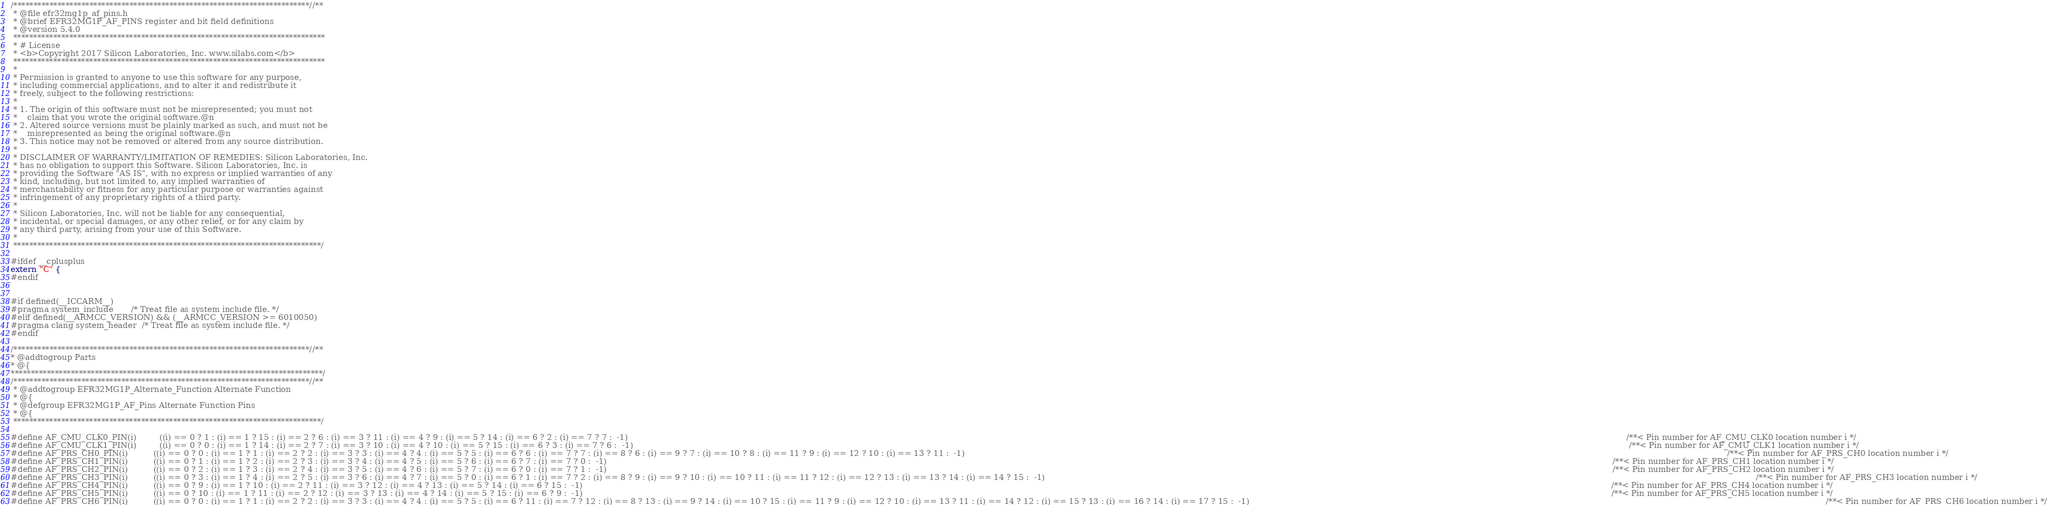<code> <loc_0><loc_0><loc_500><loc_500><_C_>/**************************************************************************//**
 * @file efr32mg1p_af_pins.h
 * @brief EFR32MG1P_AF_PINS register and bit field definitions
 * @version 5.4.0
 ******************************************************************************
 * # License
 * <b>Copyright 2017 Silicon Laboratories, Inc. www.silabs.com</b>
 ******************************************************************************
 *
 * Permission is granted to anyone to use this software for any purpose,
 * including commercial applications, and to alter it and redistribute it
 * freely, subject to the following restrictions:
 *
 * 1. The origin of this software must not be misrepresented; you must not
 *    claim that you wrote the original software.@n
 * 2. Altered source versions must be plainly marked as such, and must not be
 *    misrepresented as being the original software.@n
 * 3. This notice may not be removed or altered from any source distribution.
 *
 * DISCLAIMER OF WARRANTY/LIMITATION OF REMEDIES: Silicon Laboratories, Inc.
 * has no obligation to support this Software. Silicon Laboratories, Inc. is
 * providing the Software "AS IS", with no express or implied warranties of any
 * kind, including, but not limited to, any implied warranties of
 * merchantability or fitness for any particular purpose or warranties against
 * infringement of any proprietary rights of a third party.
 *
 * Silicon Laboratories, Inc. will not be liable for any consequential,
 * incidental, or special damages, or any other relief, or for any claim by
 * any third party, arising from your use of this Software.
 *
 *****************************************************************************/

#ifdef __cplusplus
extern "C" {
#endif


#if defined(__ICCARM__)
#pragma system_include       /* Treat file as system include file. */
#elif defined(__ARMCC_VERSION) && (__ARMCC_VERSION >= 6010050)
#pragma clang system_header  /* Treat file as system include file. */
#endif

/**************************************************************************//**
* @addtogroup Parts
* @{
******************************************************************************/
/**************************************************************************//**
 * @addtogroup EFR32MG1P_Alternate_Function Alternate Function
 * @{
 * @defgroup EFR32MG1P_AF_Pins Alternate Function Pins
 * @{
 *****************************************************************************/

#define AF_CMU_CLK0_PIN(i)         ((i) == 0 ? 1 : (i) == 1 ? 15 : (i) == 2 ? 6 : (i) == 3 ? 11 : (i) == 4 ? 9 : (i) == 5 ? 14 : (i) == 6 ? 2 : (i) == 7 ? 7 :  -1)                                                                                                                                                                                                                                                                                                                                                                                                         /**< Pin number for AF_CMU_CLK0 location number i */
#define AF_CMU_CLK1_PIN(i)         ((i) == 0 ? 0 : (i) == 1 ? 14 : (i) == 2 ? 7 : (i) == 3 ? 10 : (i) == 4 ? 10 : (i) == 5 ? 15 : (i) == 6 ? 3 : (i) == 7 ? 6 :  -1)                                                                                                                                                                                                                                                                                                                                                                                                        /**< Pin number for AF_CMU_CLK1 location number i */
#define AF_PRS_CH0_PIN(i)          ((i) == 0 ? 0 : (i) == 1 ? 1 : (i) == 2 ? 2 : (i) == 3 ? 3 : (i) == 4 ? 4 : (i) == 5 ? 5 : (i) == 6 ? 6 : (i) == 7 ? 7 : (i) == 8 ? 6 : (i) == 9 ? 7 : (i) == 10 ? 8 : (i) == 11 ? 9 : (i) == 12 ? 10 : (i) == 13 ? 11 :  -1)                                                                                                                                                                                                                                                                                                            /**< Pin number for AF_PRS_CH0 location number i */
#define AF_PRS_CH1_PIN(i)          ((i) == 0 ? 1 : (i) == 1 ? 2 : (i) == 2 ? 3 : (i) == 3 ? 4 : (i) == 4 ? 5 : (i) == 5 ? 6 : (i) == 6 ? 7 : (i) == 7 ? 0 :  -1)                                                                                                                                                                                                                                                                                                                                                                                                            /**< Pin number for AF_PRS_CH1 location number i */
#define AF_PRS_CH2_PIN(i)          ((i) == 0 ? 2 : (i) == 1 ? 3 : (i) == 2 ? 4 : (i) == 3 ? 5 : (i) == 4 ? 6 : (i) == 5 ? 7 : (i) == 6 ? 0 : (i) == 7 ? 1 :  -1)                                                                                                                                                                                                                                                                                                                                                                                                            /**< Pin number for AF_PRS_CH2 location number i */
#define AF_PRS_CH3_PIN(i)          ((i) == 0 ? 3 : (i) == 1 ? 4 : (i) == 2 ? 5 : (i) == 3 ? 6 : (i) == 4 ? 7 : (i) == 5 ? 0 : (i) == 6 ? 1 : (i) == 7 ? 2 : (i) == 8 ? 9 : (i) == 9 ? 10 : (i) == 10 ? 11 : (i) == 11 ? 12 : (i) == 12 ? 13 : (i) == 13 ? 14 : (i) == 14 ? 15 :  -1)                                                                                                                                                                                                                                                                                        /**< Pin number for AF_PRS_CH3 location number i */
#define AF_PRS_CH4_PIN(i)          ((i) == 0 ? 9 : (i) == 1 ? 10 : (i) == 2 ? 11 : (i) == 3 ? 12 : (i) == 4 ? 13 : (i) == 5 ? 14 : (i) == 6 ? 15 :  -1)                                                                                                                                                                                                                                                                                                                                                                                                                     /**< Pin number for AF_PRS_CH4 location number i */
#define AF_PRS_CH5_PIN(i)          ((i) == 0 ? 10 : (i) == 1 ? 11 : (i) == 2 ? 12 : (i) == 3 ? 13 : (i) == 4 ? 14 : (i) == 5 ? 15 : (i) == 6 ? 9 :  -1)                                                                                                                                                                                                                                                                                                                                                                                                                     /**< Pin number for AF_PRS_CH5 location number i */
#define AF_PRS_CH6_PIN(i)          ((i) == 0 ? 0 : (i) == 1 ? 1 : (i) == 2 ? 2 : (i) == 3 ? 3 : (i) == 4 ? 4 : (i) == 5 ? 5 : (i) == 6 ? 11 : (i) == 7 ? 12 : (i) == 8 ? 13 : (i) == 9 ? 14 : (i) == 10 ? 15 : (i) == 11 ? 9 : (i) == 12 ? 10 : (i) == 13 ? 11 : (i) == 14 ? 12 : (i) == 15 ? 13 : (i) == 16 ? 14 : (i) == 17 ? 15 :  -1)                                                                                                                                                                                                                                   /**< Pin number for AF_PRS_CH6 location number i */</code> 